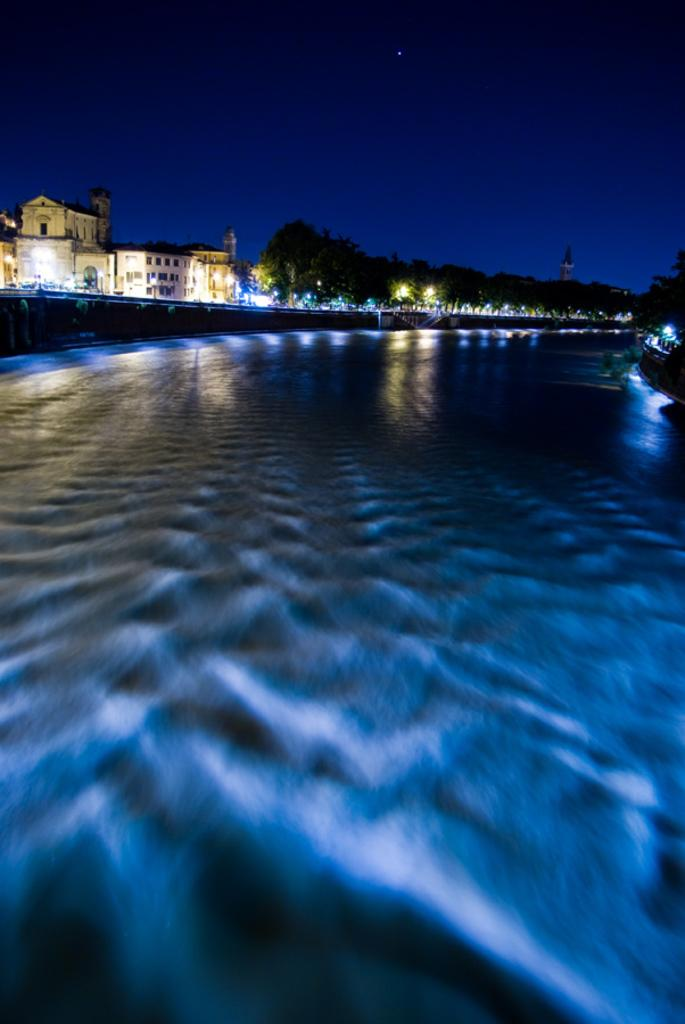What type of surface is visible in the image? There is a surface with lighting in the image. What can be seen in the background of the image? There are trees and buildings in the background of the image. Are there any light sources present in the image? Yes, there are lights in the image. What is visible in the sky in the background of the image? The sky is visible in the background of the image. What is the effect of the addition of daylight on the image? The image does not depict daylight, so it is not possible to determine the effect of its addition. 